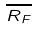<formula> <loc_0><loc_0><loc_500><loc_500>\overline { R _ { F } }</formula> 